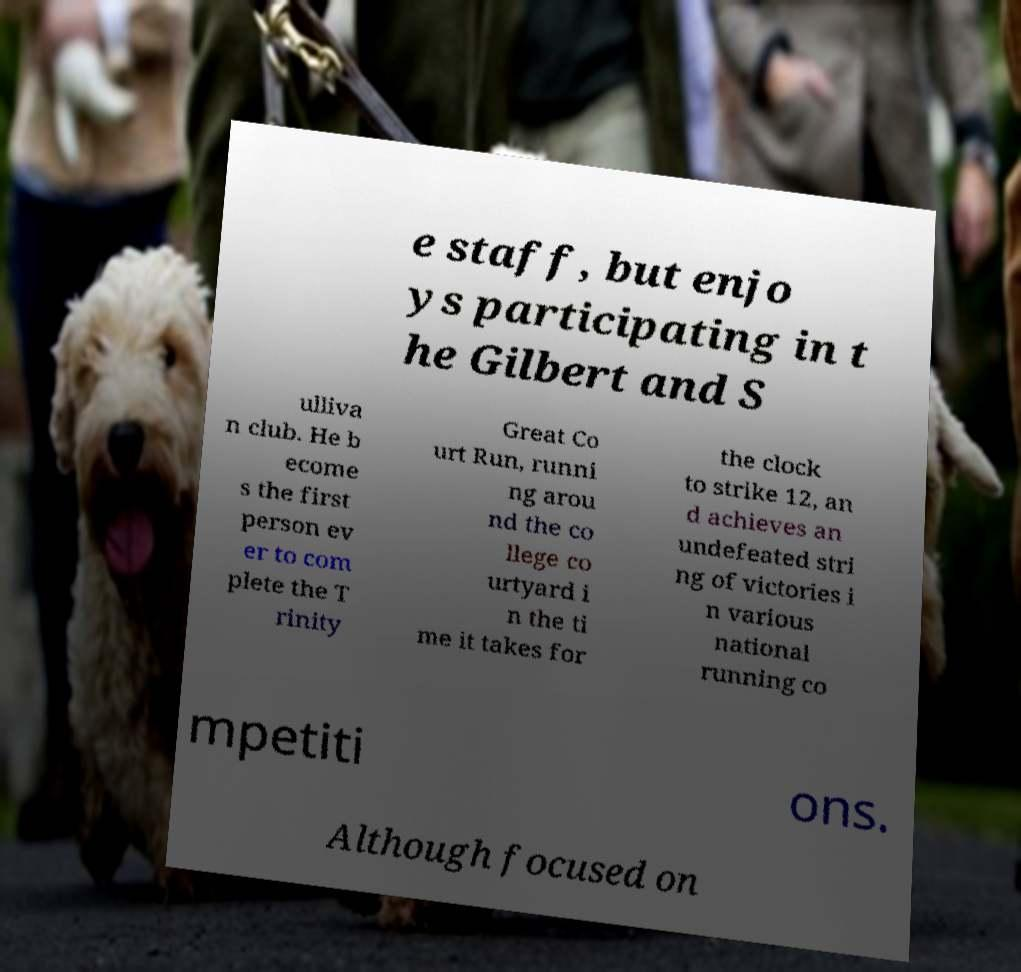I need the written content from this picture converted into text. Can you do that? e staff, but enjo ys participating in t he Gilbert and S ulliva n club. He b ecome s the first person ev er to com plete the T rinity Great Co urt Run, runni ng arou nd the co llege co urtyard i n the ti me it takes for the clock to strike 12, an d achieves an undefeated stri ng of victories i n various national running co mpetiti ons. Although focused on 